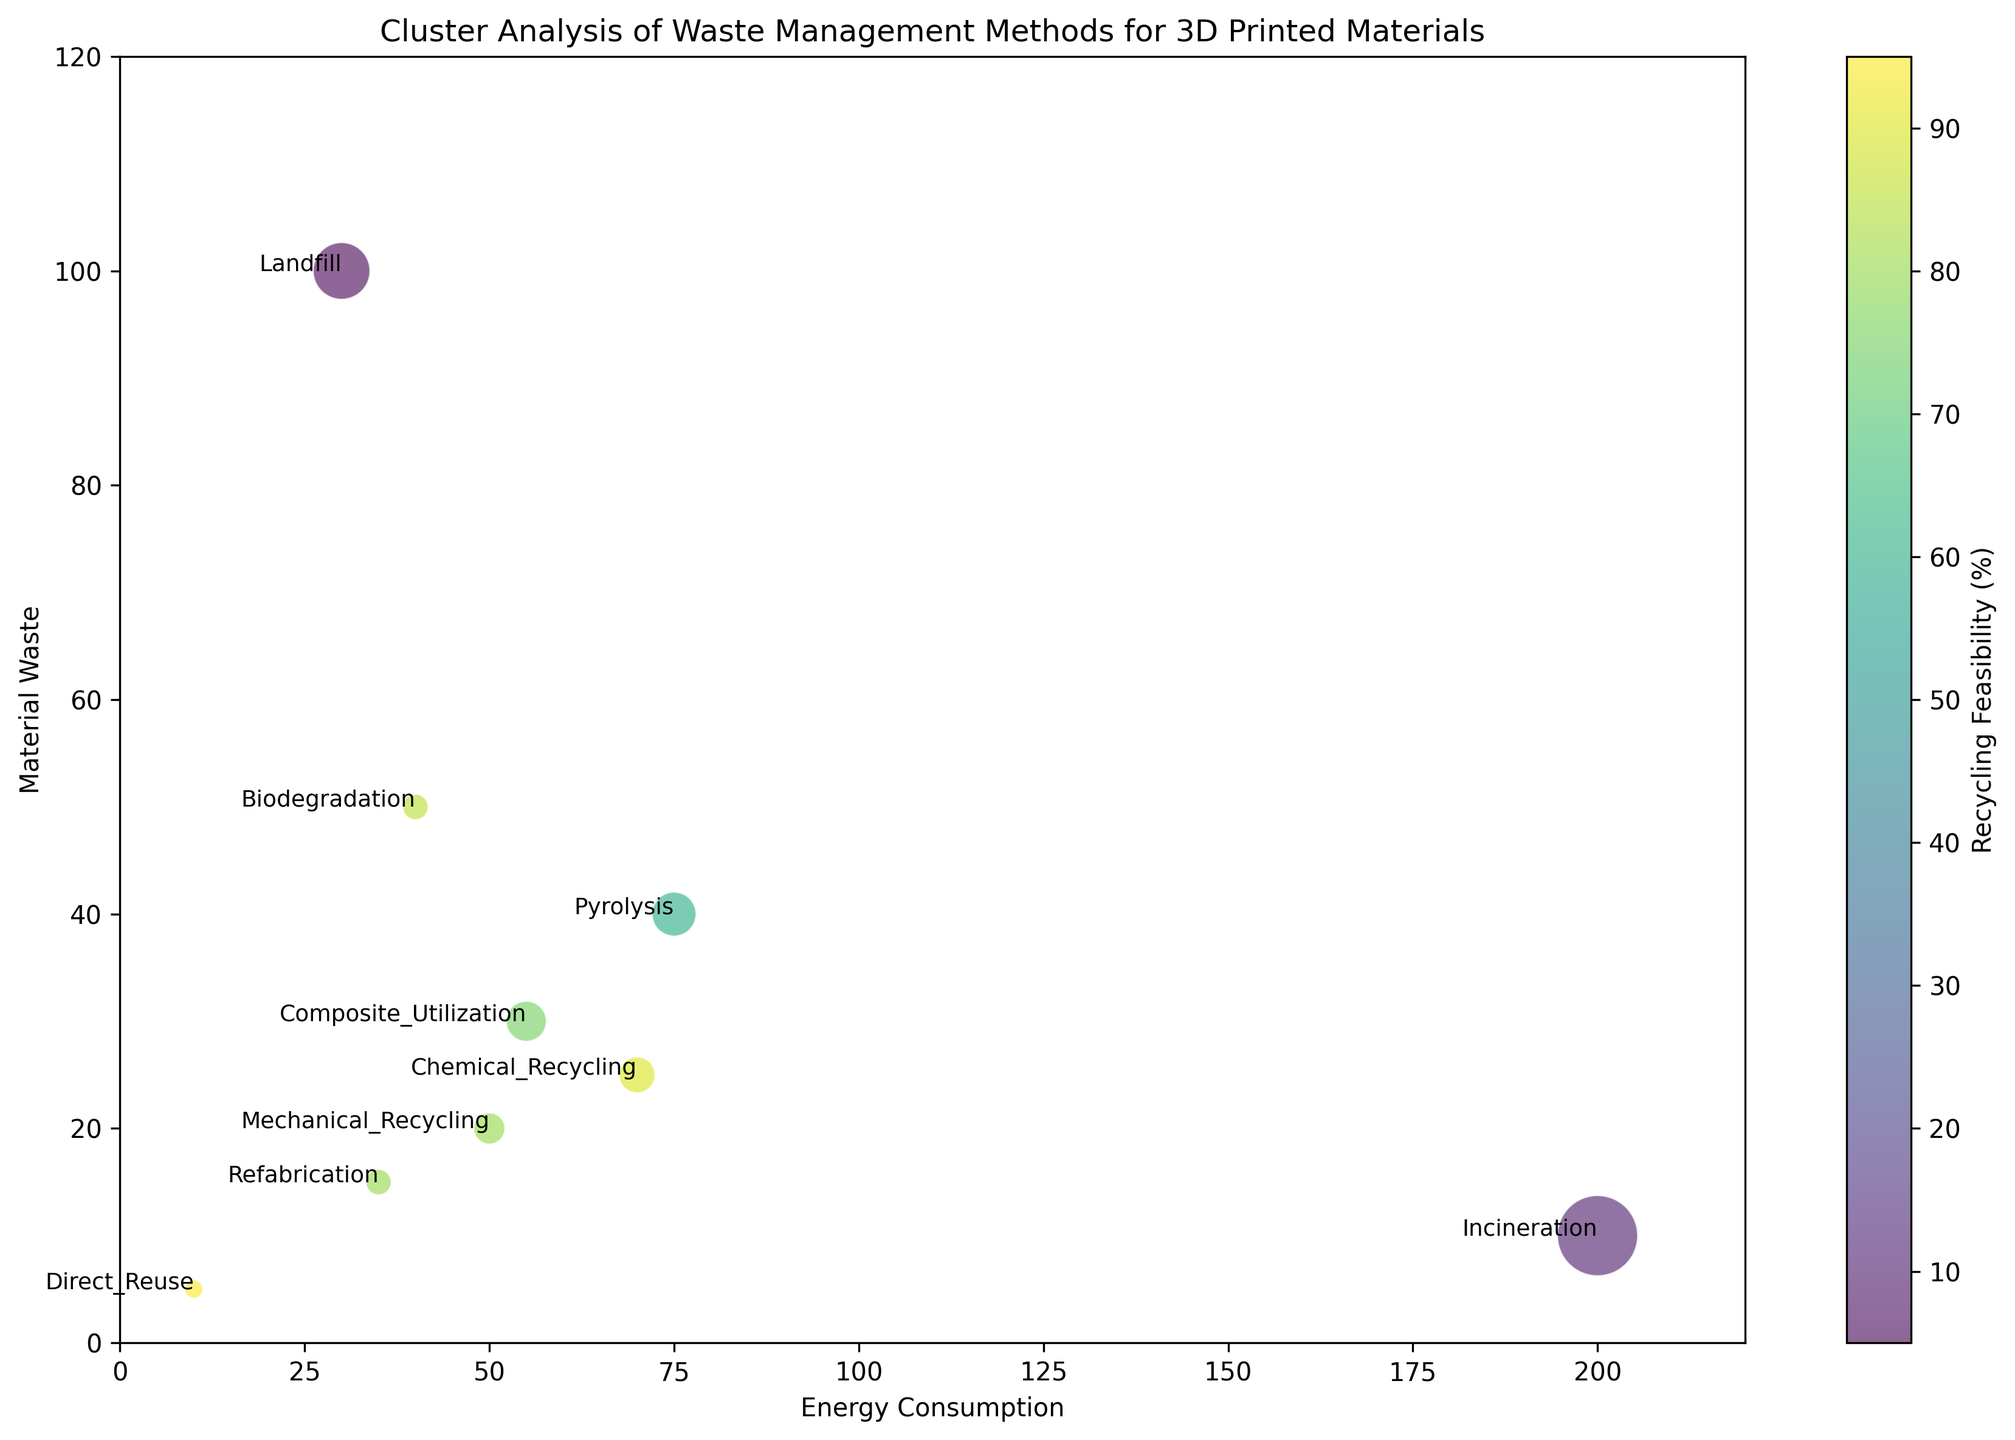What's the relationship between Direct Reuse and Incineration in terms of Energy Consumption and Recycling Feasibility? Direct Reuse has significantly lower energy consumption compared to Incineration (10 vs. 200) and a much higher recycling feasibility (95% vs. 10%).
Answer: Direct Reuse has lower energy consumption and higher recycling feasibility Which method has the highest Carbon Emissions, and what are the values for Material Waste and Recycling Feasibility for this method? Incineration shows the highest Carbon Emissions at 100. It has a Material Waste value of 10 and a Recycling Feasibility of 10%.
Answer: Incineration; Material Waste: 10, Recycling Feasibility: 10% Among Mechanical Recycling, Chemical Recycling, and Refabrication, which one has the highest Material Waste, and how do their Recycling Feasibility compare? Chemical Recycling has the highest Material Waste at 25 among the three. Mechanical Recycling and Refabrication have Recycling Feasibility values of 80% each, while Chemical Recycling has 90%.
Answer: Chemical Recycling has the highest Material Waste; Chemical Recycling: 90%, Mechanical: 80%, Refabrication: 80% Which waste management method has the smallest bubble size, and what does it signify concerning Carbon Emissions? Direct Reuse has the smallest bubble size, indicating it has the lowest Carbon Emissions at 5.
Answer: Direct Reuse, Carbon Emissions: 5 How does Pyrolysis compare to Biodegradation in terms of Energy Consumption and Material Waste? Pyrolysis has higher Energy Consumption (75 vs. 40) and Material Waste (40 vs. 50) than Biodegradation.
Answer: Pyrolysis has higher Energy Consumption and Material Waste What is the average Energy Consumption for methods with Recycling Feasibility above 80%? Methods with Recycling Feasibility above 80% are Mechanical Recycling, Chemical Recycling, Direct Reuse, Biodegradation, and Refabrication. Their Energy Consumption values are 50, 70, 10, 40, and 35, respectively. The average is calculated as (50 + 70 + 10 + 40 + 35) / 5 = 41.
Answer: 41 Which method has the highest Material Waste and how does its Energy Consumption compare to the average Energy Consumption of all methods? Landfill has the highest Material Waste at 100. Its Energy Consumption is 30. The average Energy Consumption of all methods is calculated as (50 + 70 + 200 + 30 + 10 + 55 + 40 + 35 + 75) / 9 ≈ 62.22, so Landfill has lower than average Energy Consumption.
Answer: Landfill has the highest Material Waste; below average Energy Consumption Comparing Composite Utilization and Refabrication, which method has a higher Recycling Feasibility, and by how much is the Energy Consumption different? Refabrication has a higher Recycling Feasibility by 5% (80% vs. 75%). Composite Utilization has an Energy Consumption of 55, while Refabrication's is 35, making a difference of 20.
Answer: Refabrication has higher Recycling Feasibility by 5%; Energy Consumption differs by 20 What can be observed about the relationship between Material Waste and Carbon Emissions from the methods with the highest and lowest Recycling Feasibility? Direct Reuse has the highest Recycling Feasibility (95%) with low Material Waste (5) and Carbon Emissions (5). Landfill has the lowest Recycling Feasibility (5%) with the highest Material Waste (100) and moderate Carbon Emissions (50). Lower Recycling Feasibility methods tend to have higher Material Waste and variable Carbon Emissions.
Answer: High Recycling Feasibility methods have lower Material Waste and Carbon Emissions 